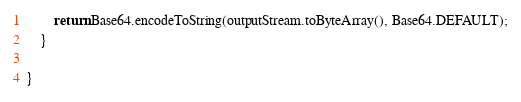Convert code to text. <code><loc_0><loc_0><loc_500><loc_500><_Java_>
        return Base64.encodeToString(outputStream.toByteArray(), Base64.DEFAULT);
    }

}
</code> 